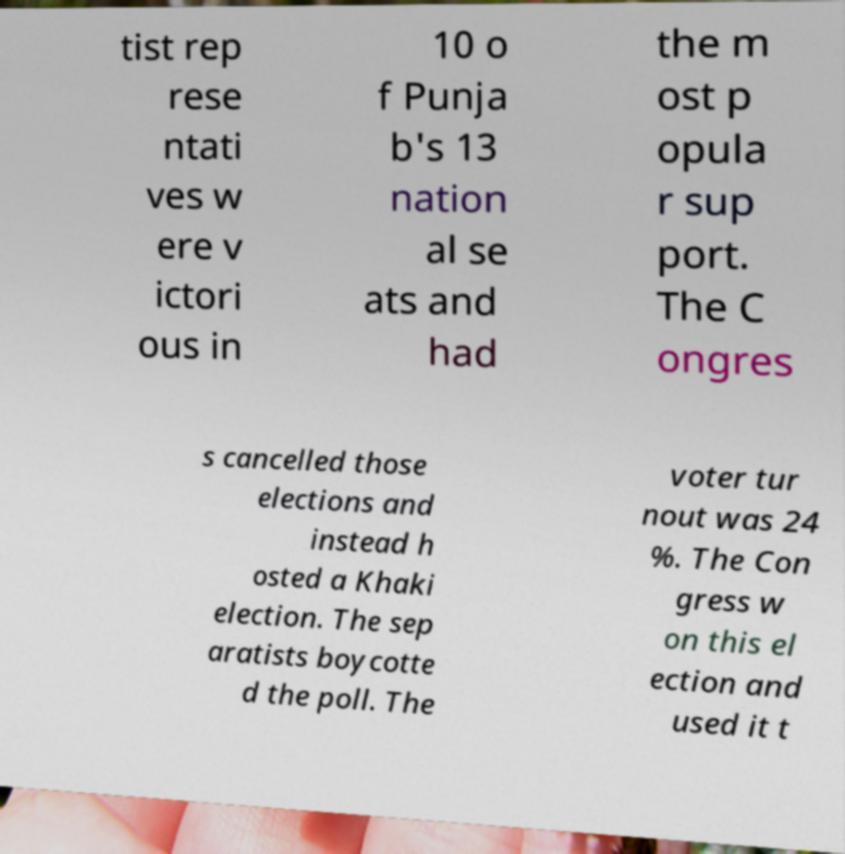I need the written content from this picture converted into text. Can you do that? tist rep rese ntati ves w ere v ictori ous in 10 o f Punja b's 13 nation al se ats and had the m ost p opula r sup port. The C ongres s cancelled those elections and instead h osted a Khaki election. The sep aratists boycotte d the poll. The voter tur nout was 24 %. The Con gress w on this el ection and used it t 